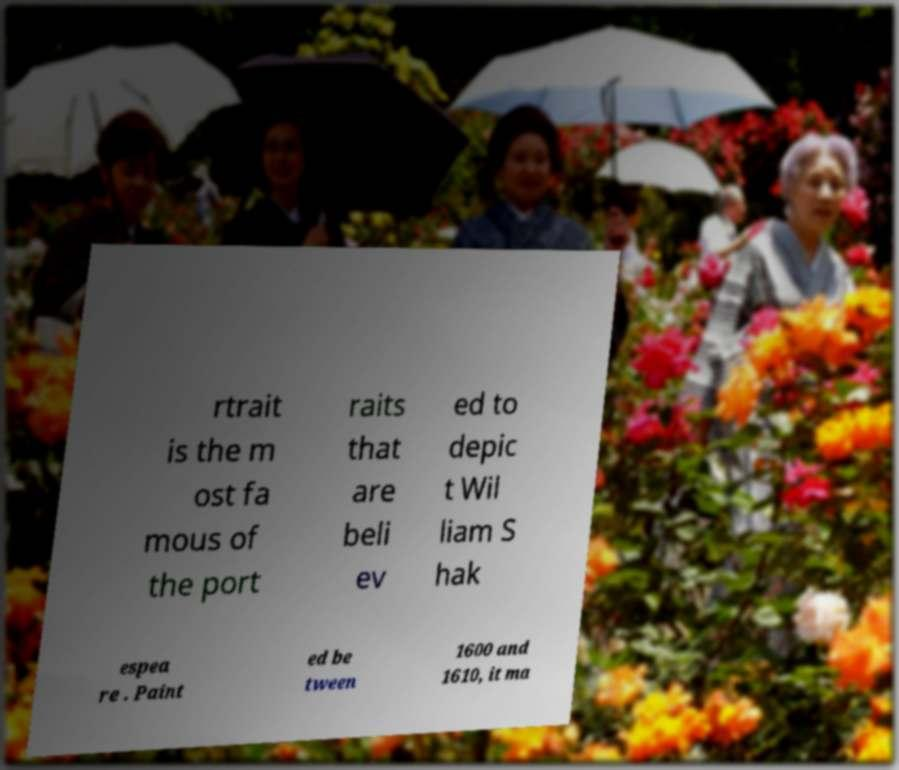For documentation purposes, I need the text within this image transcribed. Could you provide that? rtrait is the m ost fa mous of the port raits that are beli ev ed to depic t Wil liam S hak espea re . Paint ed be tween 1600 and 1610, it ma 